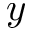Convert formula to latex. <formula><loc_0><loc_0><loc_500><loc_500>y</formula> 